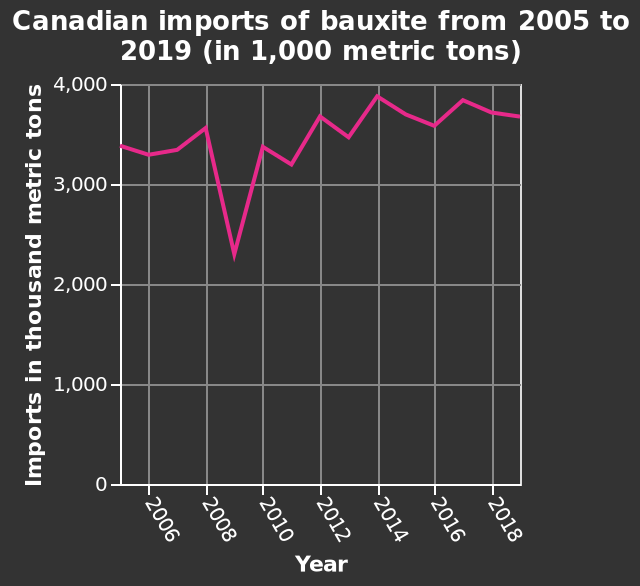<image>
please summary the statistics and relations of the chart The year with the lowest import of bauxite was 2009. Although the results fluctuate from year to year, the graph tends to show a general increase in bauxite imports over time, with the exception of 2009, where there was a large decrease in imports. Was there any exception to the general increase in bauxite imports over time? Yes, the exception was in 2009 where there was a large decrease in imports. 